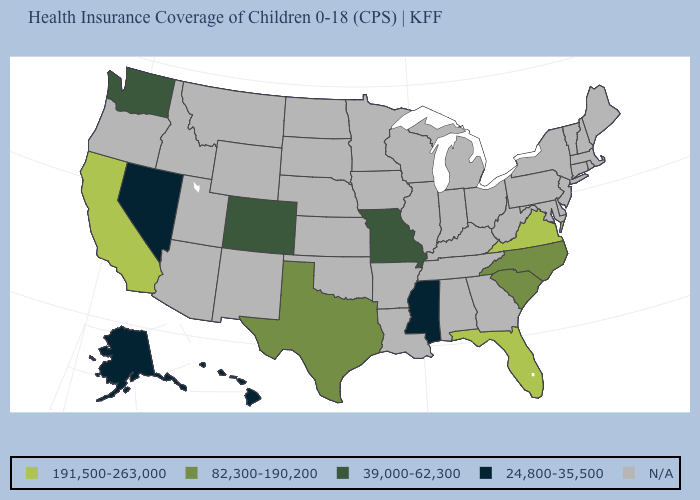Name the states that have a value in the range 24,800-35,500?
Answer briefly. Alaska, Hawaii, Mississippi, Nevada. How many symbols are there in the legend?
Concise answer only. 5. Does the map have missing data?
Answer briefly. Yes. What is the lowest value in the West?
Keep it brief. 24,800-35,500. Does California have the highest value in the USA?
Write a very short answer. Yes. Does Florida have the highest value in the USA?
Answer briefly. Yes. What is the value of Montana?
Answer briefly. N/A. Does Virginia have the lowest value in the South?
Answer briefly. No. What is the lowest value in the USA?
Answer briefly. 24,800-35,500. Among the states that border Arizona , does Nevada have the highest value?
Concise answer only. No. What is the value of Utah?
Concise answer only. N/A. Which states have the highest value in the USA?
Keep it brief. California, Florida, Virginia. 